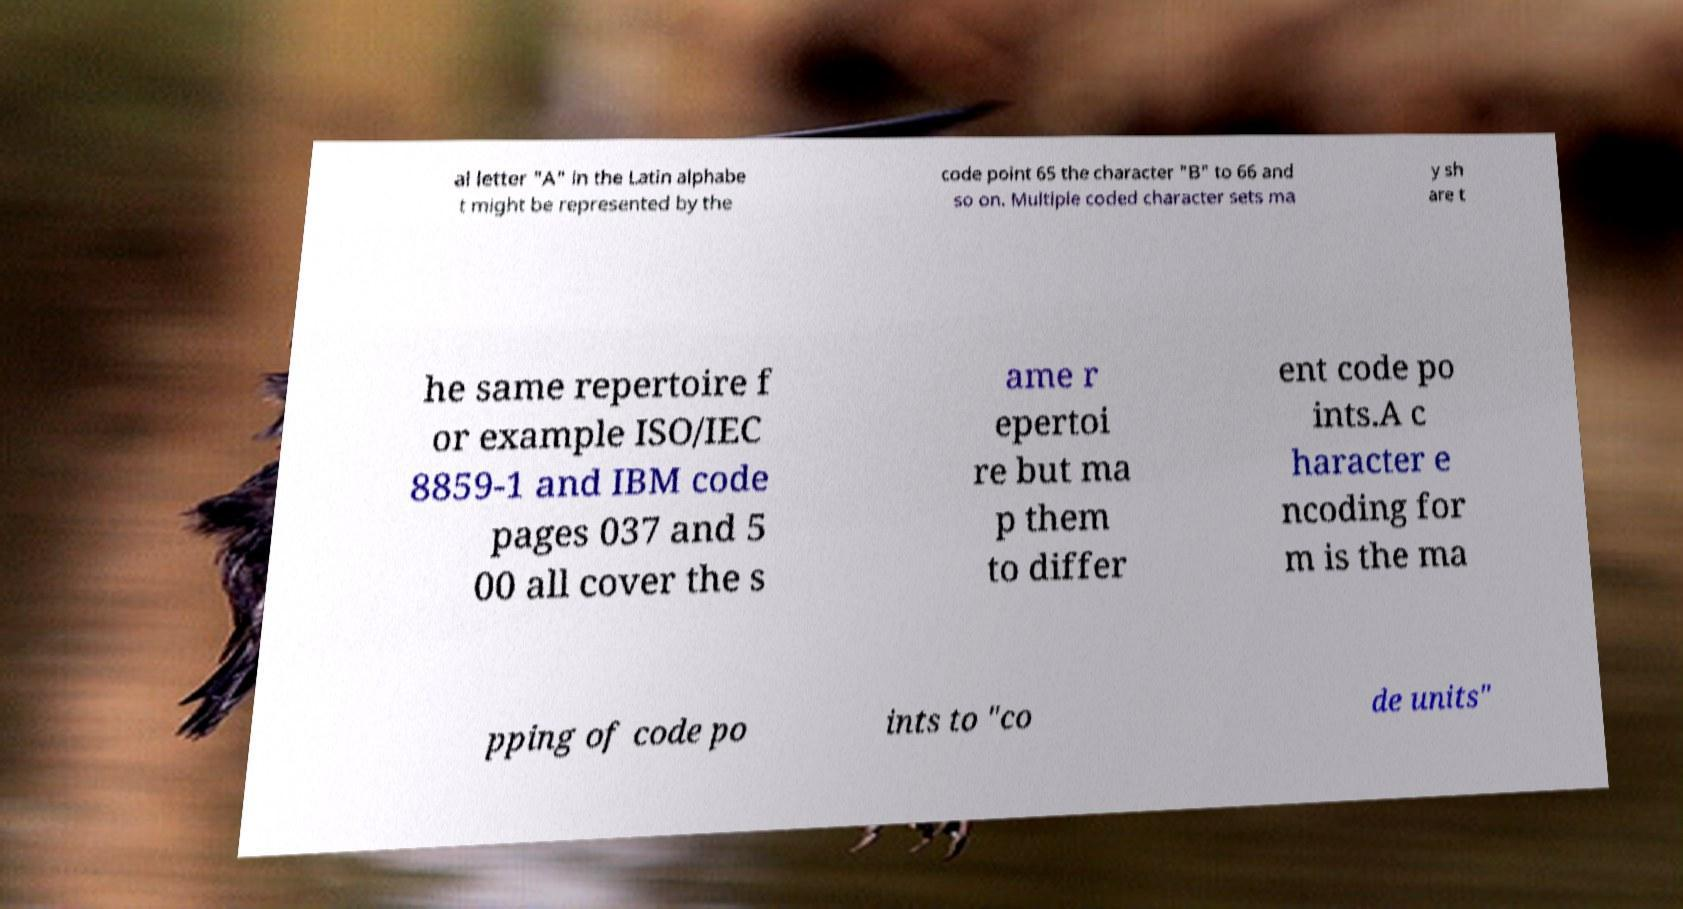I need the written content from this picture converted into text. Can you do that? al letter "A" in the Latin alphabe t might be represented by the code point 65 the character "B" to 66 and so on. Multiple coded character sets ma y sh are t he same repertoire f or example ISO/IEC 8859-1 and IBM code pages 037 and 5 00 all cover the s ame r epertoi re but ma p them to differ ent code po ints.A c haracter e ncoding for m is the ma pping of code po ints to "co de units" 